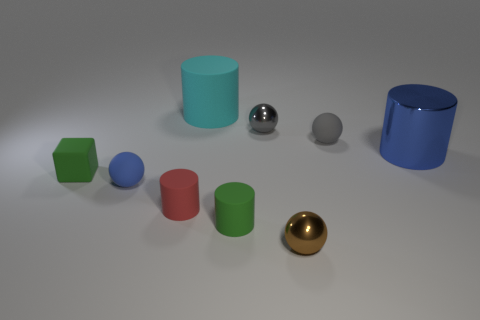How many small objects are either red matte objects or metal cylinders?
Make the answer very short. 1. What number of blue things have the same material as the tiny red object?
Make the answer very short. 1. There is a metallic ball in front of the big blue cylinder; how big is it?
Your answer should be very brief. Small. There is a large shiny thing right of the small matte object that is on the right side of the small brown object; what is its shape?
Give a very brief answer. Cylinder. There is a object that is behind the tiny metal object that is behind the small brown object; what number of large cyan objects are on the left side of it?
Make the answer very short. 0. Is the number of matte cylinders in front of the tiny red rubber cylinder less than the number of tiny metal objects?
Keep it short and to the point. Yes. What shape is the tiny metallic object behind the red rubber thing?
Ensure brevity in your answer.  Sphere. There is a tiny green matte object that is on the right side of the matte sphere on the left side of the metallic ball that is in front of the large metal cylinder; what is its shape?
Your answer should be compact. Cylinder. What number of objects are either small gray objects or small green matte cylinders?
Keep it short and to the point. 3. There is a gray object to the right of the small brown ball; is its shape the same as the small green rubber thing that is right of the small blue object?
Your answer should be compact. No. 